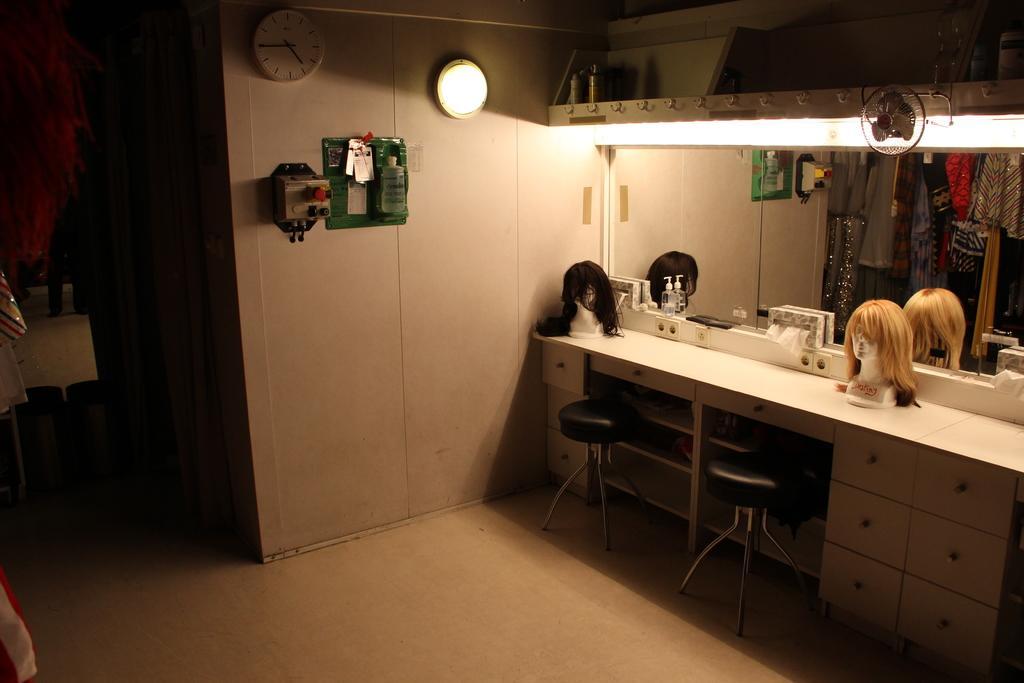How would you summarize this image in a sentence or two? In this image we can see mannequins, tissue holder, clothes hanged to the hangers, ceiling fan, electric lights, daily essentials, seating stools, cupboard and a wall clock to the wall. 